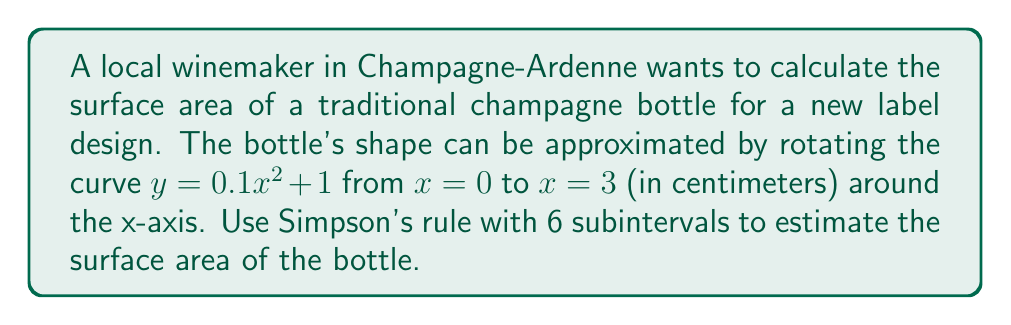Give your solution to this math problem. To calculate the surface area using Simpson's rule, we follow these steps:

1) The formula for the surface area of revolution is:
   $$S = 2\pi \int_a^b y \sqrt{1 + (dy/dx)^2} dx$$

2) For our curve $y = 0.1x^2 + 1$, we have:
   $dy/dx = 0.2x$

3) Substituting into the integrand:
   $$f(x) = y \sqrt{1 + (dy/dx)^2} = (0.1x^2 + 1)\sqrt{1 + (0.2x)^2}$$

4) Simpson's rule with n subintervals is:
   $$\int_a^b f(x)dx \approx \frac{h}{3}[f(x_0) + 4f(x_1) + 2f(x_2) + 4f(x_3) + 2f(x_4) + 4f(x_5) + f(x_6)]$$
   where $h = (b-a)/n = (3-0)/6 = 0.5$

5) Calculate the x-values:
   $x_0 = 0, x_1 = 0.5, x_2 = 1, x_3 = 1.5, x_4 = 2, x_5 = 2.5, x_6 = 3$

6) Calculate the corresponding f(x) values:
   $f(0) = 1$
   $f(0.5) \approx 1.0124$
   $f(1) \approx 1.0954$
   $f(1.5) \approx 1.2507$
   $f(2) \approx 1.4870$
   $f(2.5) \approx 1.8104$
   $f(3) \approx 2.2255$

7) Apply Simpson's rule:
   $$S \approx 2\pi \cdot \frac{0.5}{3}[1 + 4(1.0124) + 2(1.0954) + 4(1.2507) + 2(1.4870) + 4(1.8104) + 2.2255]$$
   $$S \approx 2\pi \cdot \frac{0.5}{3}[19.3129] \approx 20.2415 \text{ cm}^2$$

Therefore, the estimated surface area of the champagne bottle is approximately 20.24 cm².
Answer: 20.24 cm² 